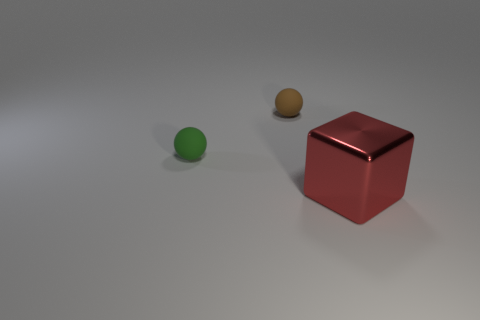There is another small object that is the same shape as the small green object; what is it made of?
Ensure brevity in your answer.  Rubber. Is the number of big red matte cylinders greater than the number of small brown balls?
Your answer should be very brief. No. Are the red object and the tiny ball that is to the left of the brown sphere made of the same material?
Provide a succinct answer. No. There is a block that is to the right of the rubber sphere that is in front of the brown thing; what number of tiny rubber objects are behind it?
Ensure brevity in your answer.  2. Is the number of large metal things that are in front of the small brown ball less than the number of brown balls behind the metal object?
Offer a terse response. No. What number of other objects are there of the same material as the tiny brown object?
Offer a terse response. 1. What is the material of the green ball that is the same size as the brown rubber object?
Provide a short and direct response. Rubber. How many green objects are either balls or tiny matte blocks?
Keep it short and to the point. 1. What is the color of the object that is in front of the brown rubber sphere and on the right side of the tiny green rubber object?
Offer a very short reply. Red. Is the cube that is right of the green sphere made of the same material as the tiny sphere in front of the small brown matte ball?
Keep it short and to the point. No. 